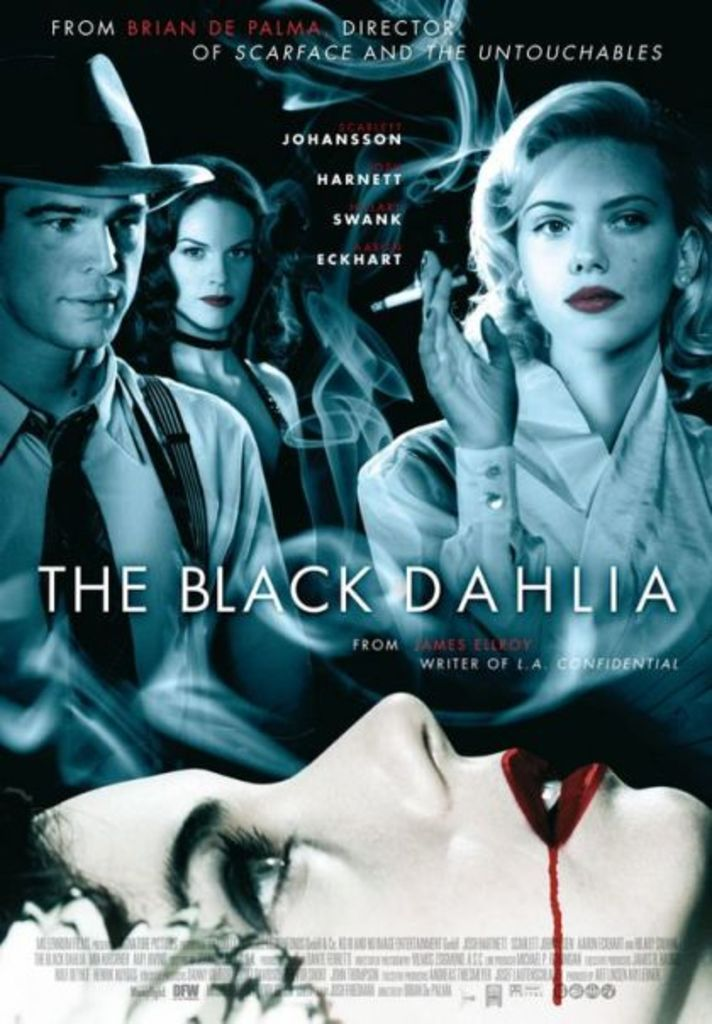Could you tell me more about the design elements used in this poster? The poster uses a color palette dominated by blues and blacks, creating a tense and foreboding atmosphere. The overlapping images of the actors' faces contribute to a feeling of complexity and intrigue, while the shadowy figure in the background and the image of the deceased character hint at the film's murder mystery elements. 